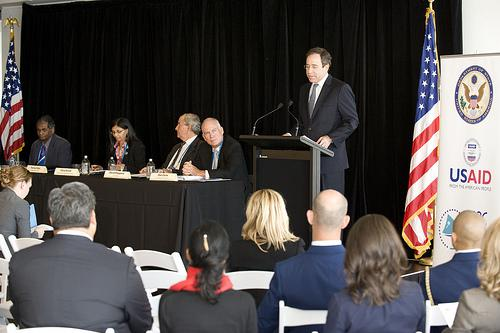Question: what organization is this for?
Choices:
A. US AID.
B. Naacp.
C. Unicef.
D. Usaa.
Answer with the letter. Answer: A Question: what country is the flag?
Choices:
A. USA.
B. Japan.
C. Spain.
D. Portugal.
Answer with the letter. Answer: A Question: what color is the background?
Choices:
A. Black.
B. Red.
C. Orange.
D. Green.
Answer with the letter. Answer: A Question: what gender is the person speaking?
Choices:
A. Female.
B. Transgender.
C. Gender-fluid.
D. Male.
Answer with the letter. Answer: D 